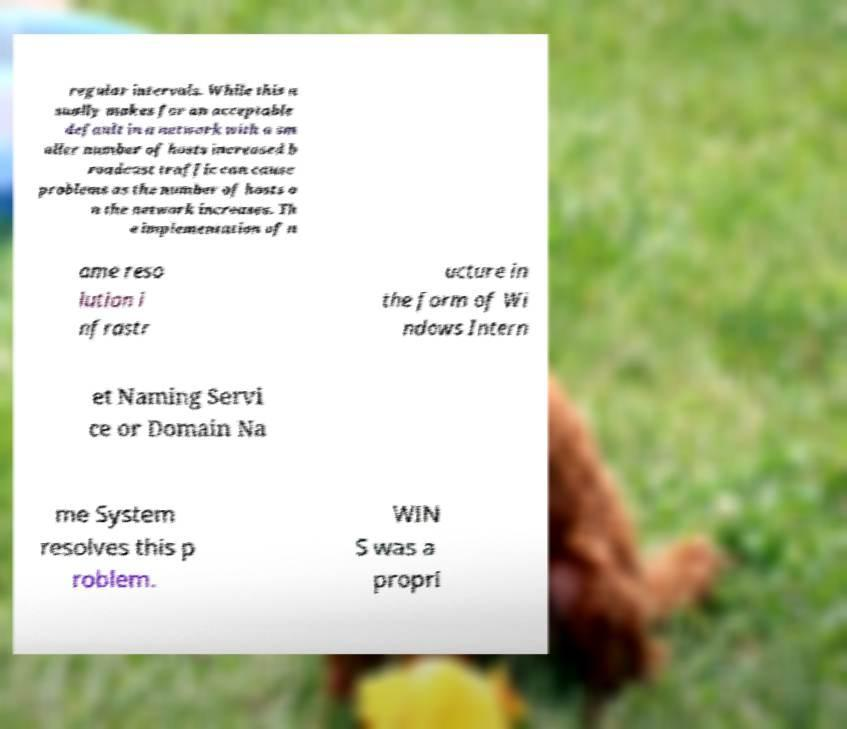I need the written content from this picture converted into text. Can you do that? regular intervals. While this u sually makes for an acceptable default in a network with a sm aller number of hosts increased b roadcast traffic can cause problems as the number of hosts o n the network increases. Th e implementation of n ame reso lution i nfrastr ucture in the form of Wi ndows Intern et Naming Servi ce or Domain Na me System resolves this p roblem. WIN S was a propri 